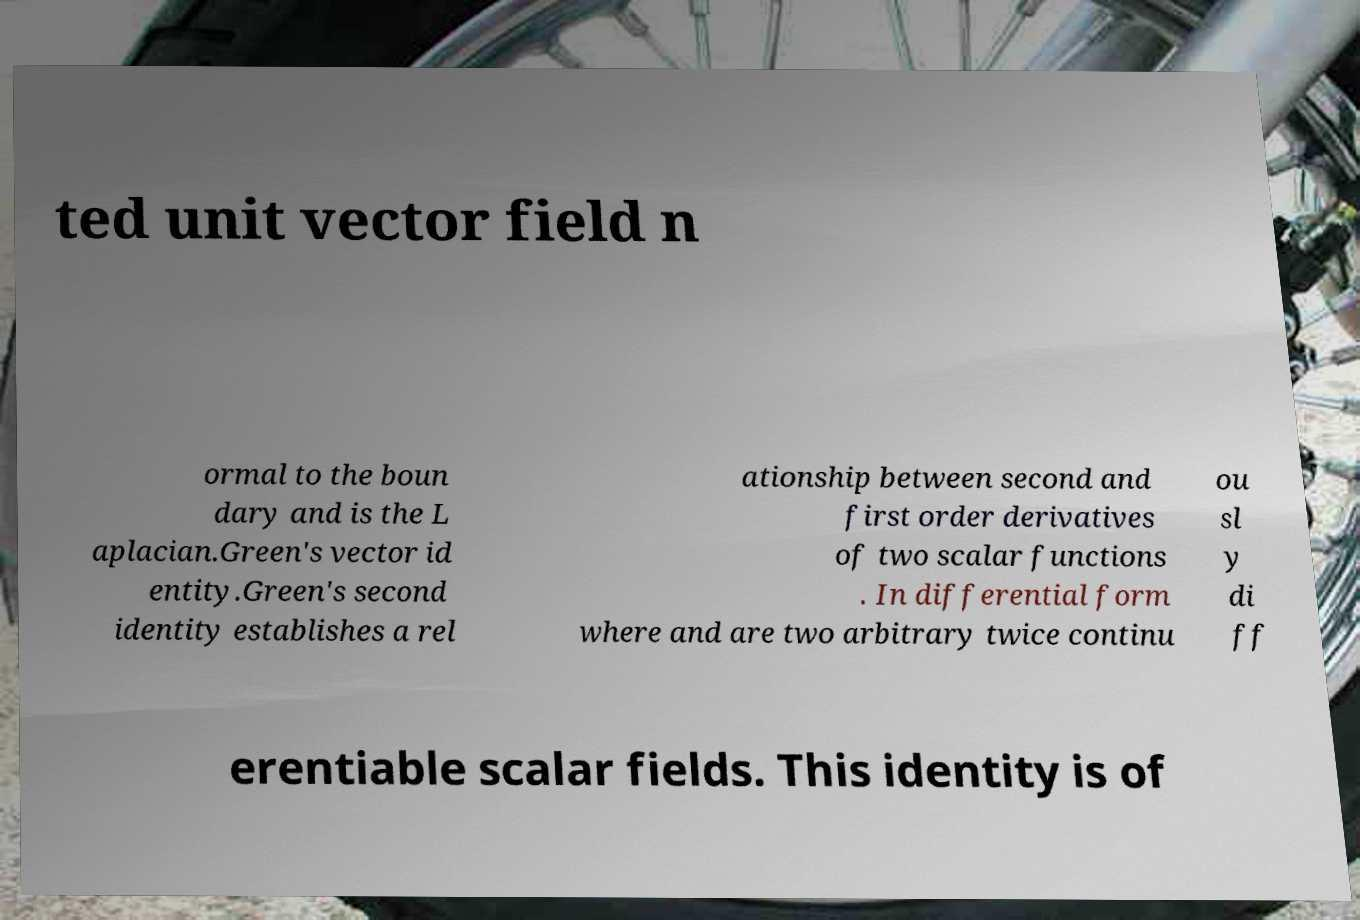Could you extract and type out the text from this image? ted unit vector field n ormal to the boun dary and is the L aplacian.Green's vector id entity.Green's second identity establishes a rel ationship between second and first order derivatives of two scalar functions . In differential form where and are two arbitrary twice continu ou sl y di ff erentiable scalar fields. This identity is of 